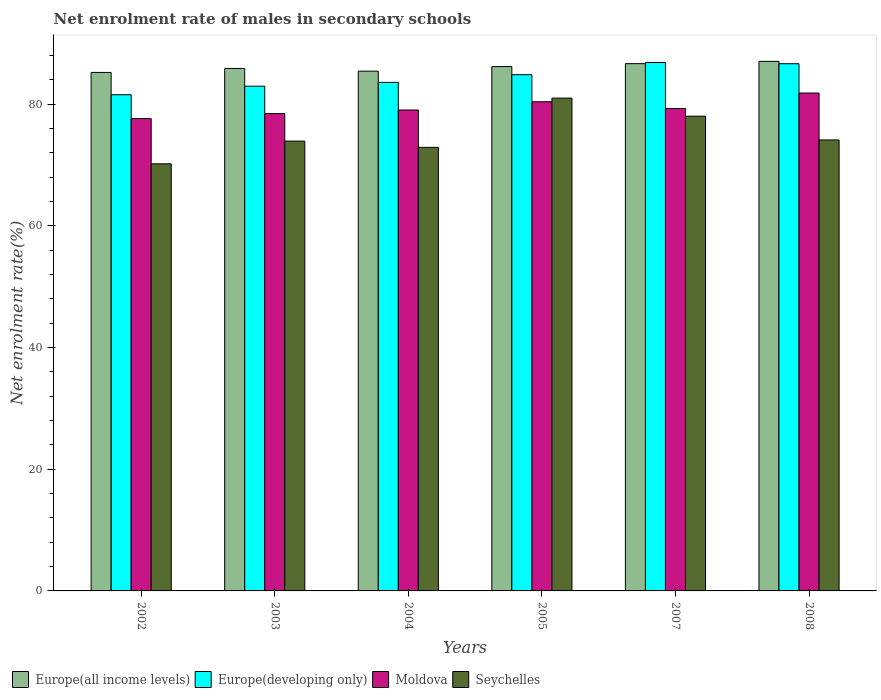How many different coloured bars are there?
Make the answer very short. 4. How many bars are there on the 3rd tick from the left?
Provide a short and direct response. 4. What is the label of the 3rd group of bars from the left?
Keep it short and to the point. 2004. What is the net enrolment rate of males in secondary schools in Moldova in 2004?
Your answer should be compact. 79.05. Across all years, what is the maximum net enrolment rate of males in secondary schools in Europe(developing only)?
Your answer should be compact. 86.86. Across all years, what is the minimum net enrolment rate of males in secondary schools in Europe(developing only)?
Your answer should be compact. 81.56. In which year was the net enrolment rate of males in secondary schools in Moldova maximum?
Offer a very short reply. 2008. In which year was the net enrolment rate of males in secondary schools in Seychelles minimum?
Make the answer very short. 2002. What is the total net enrolment rate of males in secondary schools in Europe(developing only) in the graph?
Your answer should be compact. 506.49. What is the difference between the net enrolment rate of males in secondary schools in Europe(all income levels) in 2002 and that in 2008?
Offer a very short reply. -1.82. What is the difference between the net enrolment rate of males in secondary schools in Europe(all income levels) in 2007 and the net enrolment rate of males in secondary schools in Seychelles in 2005?
Make the answer very short. 5.67. What is the average net enrolment rate of males in secondary schools in Europe(all income levels) per year?
Ensure brevity in your answer.  86.08. In the year 2004, what is the difference between the net enrolment rate of males in secondary schools in Moldova and net enrolment rate of males in secondary schools in Seychelles?
Provide a short and direct response. 6.14. In how many years, is the net enrolment rate of males in secondary schools in Europe(all income levels) greater than 52 %?
Ensure brevity in your answer.  6. What is the ratio of the net enrolment rate of males in secondary schools in Moldova in 2004 to that in 2008?
Provide a succinct answer. 0.97. Is the net enrolment rate of males in secondary schools in Seychelles in 2002 less than that in 2003?
Provide a succinct answer. Yes. What is the difference between the highest and the second highest net enrolment rate of males in secondary schools in Moldova?
Offer a terse response. 1.43. What is the difference between the highest and the lowest net enrolment rate of males in secondary schools in Seychelles?
Offer a terse response. 10.8. What does the 1st bar from the left in 2003 represents?
Make the answer very short. Europe(all income levels). What does the 4th bar from the right in 2003 represents?
Offer a very short reply. Europe(all income levels). How many bars are there?
Make the answer very short. 24. Are all the bars in the graph horizontal?
Give a very brief answer. No. How many years are there in the graph?
Your answer should be very brief. 6. What is the difference between two consecutive major ticks on the Y-axis?
Your answer should be very brief. 20. Where does the legend appear in the graph?
Make the answer very short. Bottom left. What is the title of the graph?
Your answer should be compact. Net enrolment rate of males in secondary schools. What is the label or title of the X-axis?
Your answer should be compact. Years. What is the label or title of the Y-axis?
Offer a very short reply. Net enrolment rate(%). What is the Net enrolment rate(%) in Europe(all income levels) in 2002?
Keep it short and to the point. 85.23. What is the Net enrolment rate(%) of Europe(developing only) in 2002?
Give a very brief answer. 81.56. What is the Net enrolment rate(%) of Moldova in 2002?
Your response must be concise. 77.65. What is the Net enrolment rate(%) of Seychelles in 2002?
Provide a short and direct response. 70.21. What is the Net enrolment rate(%) in Europe(all income levels) in 2003?
Give a very brief answer. 85.88. What is the Net enrolment rate(%) of Europe(developing only) in 2003?
Your response must be concise. 82.96. What is the Net enrolment rate(%) of Moldova in 2003?
Your response must be concise. 78.47. What is the Net enrolment rate(%) of Seychelles in 2003?
Offer a very short reply. 73.94. What is the Net enrolment rate(%) in Europe(all income levels) in 2004?
Make the answer very short. 85.44. What is the Net enrolment rate(%) of Europe(developing only) in 2004?
Your answer should be compact. 83.59. What is the Net enrolment rate(%) of Moldova in 2004?
Your answer should be very brief. 79.05. What is the Net enrolment rate(%) in Seychelles in 2004?
Offer a very short reply. 72.91. What is the Net enrolment rate(%) of Europe(all income levels) in 2005?
Give a very brief answer. 86.19. What is the Net enrolment rate(%) of Europe(developing only) in 2005?
Your response must be concise. 84.86. What is the Net enrolment rate(%) in Moldova in 2005?
Give a very brief answer. 80.41. What is the Net enrolment rate(%) in Seychelles in 2005?
Your answer should be compact. 81. What is the Net enrolment rate(%) of Europe(all income levels) in 2007?
Ensure brevity in your answer.  86.67. What is the Net enrolment rate(%) in Europe(developing only) in 2007?
Keep it short and to the point. 86.86. What is the Net enrolment rate(%) in Moldova in 2007?
Your response must be concise. 79.3. What is the Net enrolment rate(%) in Seychelles in 2007?
Make the answer very short. 78.04. What is the Net enrolment rate(%) in Europe(all income levels) in 2008?
Your response must be concise. 87.05. What is the Net enrolment rate(%) of Europe(developing only) in 2008?
Give a very brief answer. 86.66. What is the Net enrolment rate(%) of Moldova in 2008?
Ensure brevity in your answer.  81.84. What is the Net enrolment rate(%) in Seychelles in 2008?
Your response must be concise. 74.13. Across all years, what is the maximum Net enrolment rate(%) in Europe(all income levels)?
Your answer should be compact. 87.05. Across all years, what is the maximum Net enrolment rate(%) of Europe(developing only)?
Your answer should be compact. 86.86. Across all years, what is the maximum Net enrolment rate(%) of Moldova?
Offer a terse response. 81.84. Across all years, what is the maximum Net enrolment rate(%) of Seychelles?
Ensure brevity in your answer.  81. Across all years, what is the minimum Net enrolment rate(%) of Europe(all income levels)?
Your answer should be compact. 85.23. Across all years, what is the minimum Net enrolment rate(%) of Europe(developing only)?
Offer a terse response. 81.56. Across all years, what is the minimum Net enrolment rate(%) of Moldova?
Your answer should be very brief. 77.65. Across all years, what is the minimum Net enrolment rate(%) of Seychelles?
Your answer should be very brief. 70.21. What is the total Net enrolment rate(%) of Europe(all income levels) in the graph?
Your answer should be compact. 516.45. What is the total Net enrolment rate(%) of Europe(developing only) in the graph?
Your answer should be very brief. 506.49. What is the total Net enrolment rate(%) of Moldova in the graph?
Your response must be concise. 476.72. What is the total Net enrolment rate(%) in Seychelles in the graph?
Provide a succinct answer. 450.22. What is the difference between the Net enrolment rate(%) in Europe(all income levels) in 2002 and that in 2003?
Your response must be concise. -0.65. What is the difference between the Net enrolment rate(%) of Europe(developing only) in 2002 and that in 2003?
Provide a short and direct response. -1.4. What is the difference between the Net enrolment rate(%) in Moldova in 2002 and that in 2003?
Make the answer very short. -0.82. What is the difference between the Net enrolment rate(%) in Seychelles in 2002 and that in 2003?
Give a very brief answer. -3.73. What is the difference between the Net enrolment rate(%) in Europe(all income levels) in 2002 and that in 2004?
Your answer should be very brief. -0.21. What is the difference between the Net enrolment rate(%) of Europe(developing only) in 2002 and that in 2004?
Keep it short and to the point. -2.03. What is the difference between the Net enrolment rate(%) of Moldova in 2002 and that in 2004?
Ensure brevity in your answer.  -1.41. What is the difference between the Net enrolment rate(%) in Seychelles in 2002 and that in 2004?
Give a very brief answer. -2.71. What is the difference between the Net enrolment rate(%) in Europe(all income levels) in 2002 and that in 2005?
Offer a terse response. -0.96. What is the difference between the Net enrolment rate(%) in Europe(developing only) in 2002 and that in 2005?
Keep it short and to the point. -3.29. What is the difference between the Net enrolment rate(%) of Moldova in 2002 and that in 2005?
Provide a short and direct response. -2.76. What is the difference between the Net enrolment rate(%) of Seychelles in 2002 and that in 2005?
Your answer should be very brief. -10.8. What is the difference between the Net enrolment rate(%) of Europe(all income levels) in 2002 and that in 2007?
Provide a succinct answer. -1.44. What is the difference between the Net enrolment rate(%) in Europe(developing only) in 2002 and that in 2007?
Provide a succinct answer. -5.29. What is the difference between the Net enrolment rate(%) of Moldova in 2002 and that in 2007?
Provide a succinct answer. -1.65. What is the difference between the Net enrolment rate(%) in Seychelles in 2002 and that in 2007?
Offer a terse response. -7.83. What is the difference between the Net enrolment rate(%) of Europe(all income levels) in 2002 and that in 2008?
Ensure brevity in your answer.  -1.82. What is the difference between the Net enrolment rate(%) of Europe(developing only) in 2002 and that in 2008?
Provide a succinct answer. -5.1. What is the difference between the Net enrolment rate(%) in Moldova in 2002 and that in 2008?
Your answer should be very brief. -4.19. What is the difference between the Net enrolment rate(%) in Seychelles in 2002 and that in 2008?
Your response must be concise. -3.92. What is the difference between the Net enrolment rate(%) of Europe(all income levels) in 2003 and that in 2004?
Make the answer very short. 0.44. What is the difference between the Net enrolment rate(%) of Europe(developing only) in 2003 and that in 2004?
Keep it short and to the point. -0.63. What is the difference between the Net enrolment rate(%) in Moldova in 2003 and that in 2004?
Your response must be concise. -0.58. What is the difference between the Net enrolment rate(%) in Seychelles in 2003 and that in 2004?
Offer a very short reply. 1.03. What is the difference between the Net enrolment rate(%) in Europe(all income levels) in 2003 and that in 2005?
Give a very brief answer. -0.31. What is the difference between the Net enrolment rate(%) of Europe(developing only) in 2003 and that in 2005?
Offer a terse response. -1.89. What is the difference between the Net enrolment rate(%) in Moldova in 2003 and that in 2005?
Give a very brief answer. -1.94. What is the difference between the Net enrolment rate(%) of Seychelles in 2003 and that in 2005?
Offer a terse response. -7.07. What is the difference between the Net enrolment rate(%) of Europe(all income levels) in 2003 and that in 2007?
Make the answer very short. -0.79. What is the difference between the Net enrolment rate(%) in Europe(developing only) in 2003 and that in 2007?
Provide a short and direct response. -3.89. What is the difference between the Net enrolment rate(%) in Moldova in 2003 and that in 2007?
Give a very brief answer. -0.83. What is the difference between the Net enrolment rate(%) in Seychelles in 2003 and that in 2007?
Give a very brief answer. -4.1. What is the difference between the Net enrolment rate(%) of Europe(all income levels) in 2003 and that in 2008?
Offer a terse response. -1.17. What is the difference between the Net enrolment rate(%) of Europe(developing only) in 2003 and that in 2008?
Offer a terse response. -3.69. What is the difference between the Net enrolment rate(%) of Moldova in 2003 and that in 2008?
Keep it short and to the point. -3.37. What is the difference between the Net enrolment rate(%) in Seychelles in 2003 and that in 2008?
Provide a short and direct response. -0.19. What is the difference between the Net enrolment rate(%) in Europe(all income levels) in 2004 and that in 2005?
Provide a short and direct response. -0.75. What is the difference between the Net enrolment rate(%) of Europe(developing only) in 2004 and that in 2005?
Ensure brevity in your answer.  -1.26. What is the difference between the Net enrolment rate(%) of Moldova in 2004 and that in 2005?
Give a very brief answer. -1.36. What is the difference between the Net enrolment rate(%) in Seychelles in 2004 and that in 2005?
Provide a succinct answer. -8.09. What is the difference between the Net enrolment rate(%) of Europe(all income levels) in 2004 and that in 2007?
Keep it short and to the point. -1.23. What is the difference between the Net enrolment rate(%) of Europe(developing only) in 2004 and that in 2007?
Your response must be concise. -3.26. What is the difference between the Net enrolment rate(%) in Moldova in 2004 and that in 2007?
Your answer should be compact. -0.25. What is the difference between the Net enrolment rate(%) in Seychelles in 2004 and that in 2007?
Give a very brief answer. -5.13. What is the difference between the Net enrolment rate(%) in Europe(all income levels) in 2004 and that in 2008?
Keep it short and to the point. -1.61. What is the difference between the Net enrolment rate(%) in Europe(developing only) in 2004 and that in 2008?
Your response must be concise. -3.07. What is the difference between the Net enrolment rate(%) in Moldova in 2004 and that in 2008?
Your answer should be compact. -2.79. What is the difference between the Net enrolment rate(%) of Seychelles in 2004 and that in 2008?
Provide a succinct answer. -1.22. What is the difference between the Net enrolment rate(%) of Europe(all income levels) in 2005 and that in 2007?
Your answer should be very brief. -0.48. What is the difference between the Net enrolment rate(%) of Europe(developing only) in 2005 and that in 2007?
Your answer should be compact. -2. What is the difference between the Net enrolment rate(%) in Moldova in 2005 and that in 2007?
Offer a terse response. 1.11. What is the difference between the Net enrolment rate(%) of Seychelles in 2005 and that in 2007?
Offer a terse response. 2.97. What is the difference between the Net enrolment rate(%) in Europe(all income levels) in 2005 and that in 2008?
Make the answer very short. -0.86. What is the difference between the Net enrolment rate(%) in Europe(developing only) in 2005 and that in 2008?
Provide a short and direct response. -1.8. What is the difference between the Net enrolment rate(%) of Moldova in 2005 and that in 2008?
Your answer should be compact. -1.43. What is the difference between the Net enrolment rate(%) of Seychelles in 2005 and that in 2008?
Offer a terse response. 6.88. What is the difference between the Net enrolment rate(%) of Europe(all income levels) in 2007 and that in 2008?
Your response must be concise. -0.38. What is the difference between the Net enrolment rate(%) in Europe(developing only) in 2007 and that in 2008?
Offer a very short reply. 0.2. What is the difference between the Net enrolment rate(%) in Moldova in 2007 and that in 2008?
Offer a very short reply. -2.54. What is the difference between the Net enrolment rate(%) in Seychelles in 2007 and that in 2008?
Give a very brief answer. 3.91. What is the difference between the Net enrolment rate(%) of Europe(all income levels) in 2002 and the Net enrolment rate(%) of Europe(developing only) in 2003?
Your response must be concise. 2.26. What is the difference between the Net enrolment rate(%) of Europe(all income levels) in 2002 and the Net enrolment rate(%) of Moldova in 2003?
Your response must be concise. 6.76. What is the difference between the Net enrolment rate(%) in Europe(all income levels) in 2002 and the Net enrolment rate(%) in Seychelles in 2003?
Provide a succinct answer. 11.29. What is the difference between the Net enrolment rate(%) in Europe(developing only) in 2002 and the Net enrolment rate(%) in Moldova in 2003?
Provide a short and direct response. 3.1. What is the difference between the Net enrolment rate(%) of Europe(developing only) in 2002 and the Net enrolment rate(%) of Seychelles in 2003?
Ensure brevity in your answer.  7.63. What is the difference between the Net enrolment rate(%) of Moldova in 2002 and the Net enrolment rate(%) of Seychelles in 2003?
Give a very brief answer. 3.71. What is the difference between the Net enrolment rate(%) of Europe(all income levels) in 2002 and the Net enrolment rate(%) of Europe(developing only) in 2004?
Your response must be concise. 1.64. What is the difference between the Net enrolment rate(%) of Europe(all income levels) in 2002 and the Net enrolment rate(%) of Moldova in 2004?
Ensure brevity in your answer.  6.18. What is the difference between the Net enrolment rate(%) of Europe(all income levels) in 2002 and the Net enrolment rate(%) of Seychelles in 2004?
Your response must be concise. 12.32. What is the difference between the Net enrolment rate(%) in Europe(developing only) in 2002 and the Net enrolment rate(%) in Moldova in 2004?
Ensure brevity in your answer.  2.51. What is the difference between the Net enrolment rate(%) in Europe(developing only) in 2002 and the Net enrolment rate(%) in Seychelles in 2004?
Your answer should be compact. 8.65. What is the difference between the Net enrolment rate(%) of Moldova in 2002 and the Net enrolment rate(%) of Seychelles in 2004?
Your answer should be compact. 4.73. What is the difference between the Net enrolment rate(%) of Europe(all income levels) in 2002 and the Net enrolment rate(%) of Europe(developing only) in 2005?
Your answer should be compact. 0.37. What is the difference between the Net enrolment rate(%) of Europe(all income levels) in 2002 and the Net enrolment rate(%) of Moldova in 2005?
Make the answer very short. 4.82. What is the difference between the Net enrolment rate(%) of Europe(all income levels) in 2002 and the Net enrolment rate(%) of Seychelles in 2005?
Offer a terse response. 4.22. What is the difference between the Net enrolment rate(%) of Europe(developing only) in 2002 and the Net enrolment rate(%) of Moldova in 2005?
Provide a succinct answer. 1.15. What is the difference between the Net enrolment rate(%) in Europe(developing only) in 2002 and the Net enrolment rate(%) in Seychelles in 2005?
Offer a terse response. 0.56. What is the difference between the Net enrolment rate(%) in Moldova in 2002 and the Net enrolment rate(%) in Seychelles in 2005?
Make the answer very short. -3.36. What is the difference between the Net enrolment rate(%) of Europe(all income levels) in 2002 and the Net enrolment rate(%) of Europe(developing only) in 2007?
Ensure brevity in your answer.  -1.63. What is the difference between the Net enrolment rate(%) in Europe(all income levels) in 2002 and the Net enrolment rate(%) in Moldova in 2007?
Your answer should be compact. 5.93. What is the difference between the Net enrolment rate(%) of Europe(all income levels) in 2002 and the Net enrolment rate(%) of Seychelles in 2007?
Provide a short and direct response. 7.19. What is the difference between the Net enrolment rate(%) of Europe(developing only) in 2002 and the Net enrolment rate(%) of Moldova in 2007?
Provide a short and direct response. 2.26. What is the difference between the Net enrolment rate(%) in Europe(developing only) in 2002 and the Net enrolment rate(%) in Seychelles in 2007?
Your answer should be very brief. 3.53. What is the difference between the Net enrolment rate(%) in Moldova in 2002 and the Net enrolment rate(%) in Seychelles in 2007?
Your answer should be very brief. -0.39. What is the difference between the Net enrolment rate(%) of Europe(all income levels) in 2002 and the Net enrolment rate(%) of Europe(developing only) in 2008?
Your response must be concise. -1.43. What is the difference between the Net enrolment rate(%) of Europe(all income levels) in 2002 and the Net enrolment rate(%) of Moldova in 2008?
Provide a short and direct response. 3.39. What is the difference between the Net enrolment rate(%) in Europe(all income levels) in 2002 and the Net enrolment rate(%) in Seychelles in 2008?
Keep it short and to the point. 11.1. What is the difference between the Net enrolment rate(%) in Europe(developing only) in 2002 and the Net enrolment rate(%) in Moldova in 2008?
Provide a short and direct response. -0.28. What is the difference between the Net enrolment rate(%) in Europe(developing only) in 2002 and the Net enrolment rate(%) in Seychelles in 2008?
Offer a very short reply. 7.43. What is the difference between the Net enrolment rate(%) of Moldova in 2002 and the Net enrolment rate(%) of Seychelles in 2008?
Offer a terse response. 3.52. What is the difference between the Net enrolment rate(%) in Europe(all income levels) in 2003 and the Net enrolment rate(%) in Europe(developing only) in 2004?
Offer a very short reply. 2.29. What is the difference between the Net enrolment rate(%) in Europe(all income levels) in 2003 and the Net enrolment rate(%) in Moldova in 2004?
Make the answer very short. 6.83. What is the difference between the Net enrolment rate(%) in Europe(all income levels) in 2003 and the Net enrolment rate(%) in Seychelles in 2004?
Ensure brevity in your answer.  12.97. What is the difference between the Net enrolment rate(%) in Europe(developing only) in 2003 and the Net enrolment rate(%) in Moldova in 2004?
Make the answer very short. 3.91. What is the difference between the Net enrolment rate(%) of Europe(developing only) in 2003 and the Net enrolment rate(%) of Seychelles in 2004?
Give a very brief answer. 10.05. What is the difference between the Net enrolment rate(%) of Moldova in 2003 and the Net enrolment rate(%) of Seychelles in 2004?
Offer a terse response. 5.56. What is the difference between the Net enrolment rate(%) of Europe(all income levels) in 2003 and the Net enrolment rate(%) of Moldova in 2005?
Provide a short and direct response. 5.47. What is the difference between the Net enrolment rate(%) of Europe(all income levels) in 2003 and the Net enrolment rate(%) of Seychelles in 2005?
Keep it short and to the point. 4.87. What is the difference between the Net enrolment rate(%) in Europe(developing only) in 2003 and the Net enrolment rate(%) in Moldova in 2005?
Ensure brevity in your answer.  2.56. What is the difference between the Net enrolment rate(%) of Europe(developing only) in 2003 and the Net enrolment rate(%) of Seychelles in 2005?
Provide a short and direct response. 1.96. What is the difference between the Net enrolment rate(%) in Moldova in 2003 and the Net enrolment rate(%) in Seychelles in 2005?
Give a very brief answer. -2.54. What is the difference between the Net enrolment rate(%) of Europe(all income levels) in 2003 and the Net enrolment rate(%) of Europe(developing only) in 2007?
Provide a succinct answer. -0.98. What is the difference between the Net enrolment rate(%) in Europe(all income levels) in 2003 and the Net enrolment rate(%) in Moldova in 2007?
Give a very brief answer. 6.58. What is the difference between the Net enrolment rate(%) in Europe(all income levels) in 2003 and the Net enrolment rate(%) in Seychelles in 2007?
Offer a terse response. 7.84. What is the difference between the Net enrolment rate(%) in Europe(developing only) in 2003 and the Net enrolment rate(%) in Moldova in 2007?
Your answer should be compact. 3.66. What is the difference between the Net enrolment rate(%) of Europe(developing only) in 2003 and the Net enrolment rate(%) of Seychelles in 2007?
Provide a short and direct response. 4.93. What is the difference between the Net enrolment rate(%) of Moldova in 2003 and the Net enrolment rate(%) of Seychelles in 2007?
Offer a very short reply. 0.43. What is the difference between the Net enrolment rate(%) of Europe(all income levels) in 2003 and the Net enrolment rate(%) of Europe(developing only) in 2008?
Provide a succinct answer. -0.78. What is the difference between the Net enrolment rate(%) in Europe(all income levels) in 2003 and the Net enrolment rate(%) in Moldova in 2008?
Provide a short and direct response. 4.04. What is the difference between the Net enrolment rate(%) in Europe(all income levels) in 2003 and the Net enrolment rate(%) in Seychelles in 2008?
Offer a terse response. 11.75. What is the difference between the Net enrolment rate(%) of Europe(developing only) in 2003 and the Net enrolment rate(%) of Moldova in 2008?
Provide a succinct answer. 1.12. What is the difference between the Net enrolment rate(%) in Europe(developing only) in 2003 and the Net enrolment rate(%) in Seychelles in 2008?
Keep it short and to the point. 8.84. What is the difference between the Net enrolment rate(%) in Moldova in 2003 and the Net enrolment rate(%) in Seychelles in 2008?
Ensure brevity in your answer.  4.34. What is the difference between the Net enrolment rate(%) in Europe(all income levels) in 2004 and the Net enrolment rate(%) in Europe(developing only) in 2005?
Offer a terse response. 0.58. What is the difference between the Net enrolment rate(%) of Europe(all income levels) in 2004 and the Net enrolment rate(%) of Moldova in 2005?
Your answer should be compact. 5.03. What is the difference between the Net enrolment rate(%) of Europe(all income levels) in 2004 and the Net enrolment rate(%) of Seychelles in 2005?
Give a very brief answer. 4.43. What is the difference between the Net enrolment rate(%) of Europe(developing only) in 2004 and the Net enrolment rate(%) of Moldova in 2005?
Provide a short and direct response. 3.18. What is the difference between the Net enrolment rate(%) in Europe(developing only) in 2004 and the Net enrolment rate(%) in Seychelles in 2005?
Provide a succinct answer. 2.59. What is the difference between the Net enrolment rate(%) in Moldova in 2004 and the Net enrolment rate(%) in Seychelles in 2005?
Provide a short and direct response. -1.95. What is the difference between the Net enrolment rate(%) of Europe(all income levels) in 2004 and the Net enrolment rate(%) of Europe(developing only) in 2007?
Ensure brevity in your answer.  -1.42. What is the difference between the Net enrolment rate(%) of Europe(all income levels) in 2004 and the Net enrolment rate(%) of Moldova in 2007?
Make the answer very short. 6.14. What is the difference between the Net enrolment rate(%) of Europe(all income levels) in 2004 and the Net enrolment rate(%) of Seychelles in 2007?
Provide a succinct answer. 7.4. What is the difference between the Net enrolment rate(%) of Europe(developing only) in 2004 and the Net enrolment rate(%) of Moldova in 2007?
Provide a succinct answer. 4.29. What is the difference between the Net enrolment rate(%) in Europe(developing only) in 2004 and the Net enrolment rate(%) in Seychelles in 2007?
Your response must be concise. 5.56. What is the difference between the Net enrolment rate(%) of Moldova in 2004 and the Net enrolment rate(%) of Seychelles in 2007?
Keep it short and to the point. 1.02. What is the difference between the Net enrolment rate(%) of Europe(all income levels) in 2004 and the Net enrolment rate(%) of Europe(developing only) in 2008?
Offer a very short reply. -1.22. What is the difference between the Net enrolment rate(%) in Europe(all income levels) in 2004 and the Net enrolment rate(%) in Moldova in 2008?
Provide a succinct answer. 3.6. What is the difference between the Net enrolment rate(%) in Europe(all income levels) in 2004 and the Net enrolment rate(%) in Seychelles in 2008?
Give a very brief answer. 11.31. What is the difference between the Net enrolment rate(%) in Europe(developing only) in 2004 and the Net enrolment rate(%) in Moldova in 2008?
Give a very brief answer. 1.75. What is the difference between the Net enrolment rate(%) in Europe(developing only) in 2004 and the Net enrolment rate(%) in Seychelles in 2008?
Give a very brief answer. 9.46. What is the difference between the Net enrolment rate(%) of Moldova in 2004 and the Net enrolment rate(%) of Seychelles in 2008?
Offer a terse response. 4.92. What is the difference between the Net enrolment rate(%) of Europe(all income levels) in 2005 and the Net enrolment rate(%) of Europe(developing only) in 2007?
Make the answer very short. -0.67. What is the difference between the Net enrolment rate(%) of Europe(all income levels) in 2005 and the Net enrolment rate(%) of Moldova in 2007?
Offer a very short reply. 6.89. What is the difference between the Net enrolment rate(%) in Europe(all income levels) in 2005 and the Net enrolment rate(%) in Seychelles in 2007?
Provide a short and direct response. 8.15. What is the difference between the Net enrolment rate(%) of Europe(developing only) in 2005 and the Net enrolment rate(%) of Moldova in 2007?
Provide a short and direct response. 5.56. What is the difference between the Net enrolment rate(%) in Europe(developing only) in 2005 and the Net enrolment rate(%) in Seychelles in 2007?
Provide a succinct answer. 6.82. What is the difference between the Net enrolment rate(%) of Moldova in 2005 and the Net enrolment rate(%) of Seychelles in 2007?
Ensure brevity in your answer.  2.37. What is the difference between the Net enrolment rate(%) in Europe(all income levels) in 2005 and the Net enrolment rate(%) in Europe(developing only) in 2008?
Your response must be concise. -0.47. What is the difference between the Net enrolment rate(%) in Europe(all income levels) in 2005 and the Net enrolment rate(%) in Moldova in 2008?
Your response must be concise. 4.35. What is the difference between the Net enrolment rate(%) of Europe(all income levels) in 2005 and the Net enrolment rate(%) of Seychelles in 2008?
Provide a short and direct response. 12.06. What is the difference between the Net enrolment rate(%) of Europe(developing only) in 2005 and the Net enrolment rate(%) of Moldova in 2008?
Offer a very short reply. 3.02. What is the difference between the Net enrolment rate(%) of Europe(developing only) in 2005 and the Net enrolment rate(%) of Seychelles in 2008?
Your answer should be very brief. 10.73. What is the difference between the Net enrolment rate(%) in Moldova in 2005 and the Net enrolment rate(%) in Seychelles in 2008?
Your response must be concise. 6.28. What is the difference between the Net enrolment rate(%) of Europe(all income levels) in 2007 and the Net enrolment rate(%) of Europe(developing only) in 2008?
Provide a succinct answer. 0.01. What is the difference between the Net enrolment rate(%) of Europe(all income levels) in 2007 and the Net enrolment rate(%) of Moldova in 2008?
Keep it short and to the point. 4.83. What is the difference between the Net enrolment rate(%) of Europe(all income levels) in 2007 and the Net enrolment rate(%) of Seychelles in 2008?
Ensure brevity in your answer.  12.54. What is the difference between the Net enrolment rate(%) of Europe(developing only) in 2007 and the Net enrolment rate(%) of Moldova in 2008?
Keep it short and to the point. 5.02. What is the difference between the Net enrolment rate(%) of Europe(developing only) in 2007 and the Net enrolment rate(%) of Seychelles in 2008?
Your response must be concise. 12.73. What is the difference between the Net enrolment rate(%) in Moldova in 2007 and the Net enrolment rate(%) in Seychelles in 2008?
Offer a terse response. 5.17. What is the average Net enrolment rate(%) in Europe(all income levels) per year?
Ensure brevity in your answer.  86.08. What is the average Net enrolment rate(%) of Europe(developing only) per year?
Ensure brevity in your answer.  84.42. What is the average Net enrolment rate(%) of Moldova per year?
Offer a terse response. 79.45. What is the average Net enrolment rate(%) in Seychelles per year?
Offer a terse response. 75.04. In the year 2002, what is the difference between the Net enrolment rate(%) of Europe(all income levels) and Net enrolment rate(%) of Europe(developing only)?
Make the answer very short. 3.66. In the year 2002, what is the difference between the Net enrolment rate(%) in Europe(all income levels) and Net enrolment rate(%) in Moldova?
Offer a very short reply. 7.58. In the year 2002, what is the difference between the Net enrolment rate(%) of Europe(all income levels) and Net enrolment rate(%) of Seychelles?
Provide a succinct answer. 15.02. In the year 2002, what is the difference between the Net enrolment rate(%) of Europe(developing only) and Net enrolment rate(%) of Moldova?
Ensure brevity in your answer.  3.92. In the year 2002, what is the difference between the Net enrolment rate(%) of Europe(developing only) and Net enrolment rate(%) of Seychelles?
Provide a short and direct response. 11.36. In the year 2002, what is the difference between the Net enrolment rate(%) of Moldova and Net enrolment rate(%) of Seychelles?
Offer a very short reply. 7.44. In the year 2003, what is the difference between the Net enrolment rate(%) in Europe(all income levels) and Net enrolment rate(%) in Europe(developing only)?
Ensure brevity in your answer.  2.91. In the year 2003, what is the difference between the Net enrolment rate(%) of Europe(all income levels) and Net enrolment rate(%) of Moldova?
Give a very brief answer. 7.41. In the year 2003, what is the difference between the Net enrolment rate(%) in Europe(all income levels) and Net enrolment rate(%) in Seychelles?
Make the answer very short. 11.94. In the year 2003, what is the difference between the Net enrolment rate(%) of Europe(developing only) and Net enrolment rate(%) of Moldova?
Your response must be concise. 4.5. In the year 2003, what is the difference between the Net enrolment rate(%) of Europe(developing only) and Net enrolment rate(%) of Seychelles?
Provide a succinct answer. 9.03. In the year 2003, what is the difference between the Net enrolment rate(%) in Moldova and Net enrolment rate(%) in Seychelles?
Give a very brief answer. 4.53. In the year 2004, what is the difference between the Net enrolment rate(%) of Europe(all income levels) and Net enrolment rate(%) of Europe(developing only)?
Your answer should be very brief. 1.84. In the year 2004, what is the difference between the Net enrolment rate(%) of Europe(all income levels) and Net enrolment rate(%) of Moldova?
Keep it short and to the point. 6.38. In the year 2004, what is the difference between the Net enrolment rate(%) in Europe(all income levels) and Net enrolment rate(%) in Seychelles?
Ensure brevity in your answer.  12.53. In the year 2004, what is the difference between the Net enrolment rate(%) in Europe(developing only) and Net enrolment rate(%) in Moldova?
Provide a short and direct response. 4.54. In the year 2004, what is the difference between the Net enrolment rate(%) of Europe(developing only) and Net enrolment rate(%) of Seychelles?
Ensure brevity in your answer.  10.68. In the year 2004, what is the difference between the Net enrolment rate(%) in Moldova and Net enrolment rate(%) in Seychelles?
Provide a succinct answer. 6.14. In the year 2005, what is the difference between the Net enrolment rate(%) of Europe(all income levels) and Net enrolment rate(%) of Europe(developing only)?
Your response must be concise. 1.34. In the year 2005, what is the difference between the Net enrolment rate(%) of Europe(all income levels) and Net enrolment rate(%) of Moldova?
Offer a very short reply. 5.78. In the year 2005, what is the difference between the Net enrolment rate(%) of Europe(all income levels) and Net enrolment rate(%) of Seychelles?
Ensure brevity in your answer.  5.19. In the year 2005, what is the difference between the Net enrolment rate(%) of Europe(developing only) and Net enrolment rate(%) of Moldova?
Keep it short and to the point. 4.45. In the year 2005, what is the difference between the Net enrolment rate(%) of Europe(developing only) and Net enrolment rate(%) of Seychelles?
Your answer should be very brief. 3.85. In the year 2005, what is the difference between the Net enrolment rate(%) of Moldova and Net enrolment rate(%) of Seychelles?
Your answer should be very brief. -0.59. In the year 2007, what is the difference between the Net enrolment rate(%) of Europe(all income levels) and Net enrolment rate(%) of Europe(developing only)?
Give a very brief answer. -0.19. In the year 2007, what is the difference between the Net enrolment rate(%) in Europe(all income levels) and Net enrolment rate(%) in Moldova?
Give a very brief answer. 7.37. In the year 2007, what is the difference between the Net enrolment rate(%) of Europe(all income levels) and Net enrolment rate(%) of Seychelles?
Make the answer very short. 8.63. In the year 2007, what is the difference between the Net enrolment rate(%) in Europe(developing only) and Net enrolment rate(%) in Moldova?
Your answer should be compact. 7.56. In the year 2007, what is the difference between the Net enrolment rate(%) of Europe(developing only) and Net enrolment rate(%) of Seychelles?
Provide a succinct answer. 8.82. In the year 2007, what is the difference between the Net enrolment rate(%) of Moldova and Net enrolment rate(%) of Seychelles?
Provide a short and direct response. 1.26. In the year 2008, what is the difference between the Net enrolment rate(%) of Europe(all income levels) and Net enrolment rate(%) of Europe(developing only)?
Provide a short and direct response. 0.39. In the year 2008, what is the difference between the Net enrolment rate(%) in Europe(all income levels) and Net enrolment rate(%) in Moldova?
Ensure brevity in your answer.  5.21. In the year 2008, what is the difference between the Net enrolment rate(%) of Europe(all income levels) and Net enrolment rate(%) of Seychelles?
Your answer should be very brief. 12.92. In the year 2008, what is the difference between the Net enrolment rate(%) of Europe(developing only) and Net enrolment rate(%) of Moldova?
Your answer should be compact. 4.82. In the year 2008, what is the difference between the Net enrolment rate(%) in Europe(developing only) and Net enrolment rate(%) in Seychelles?
Provide a short and direct response. 12.53. In the year 2008, what is the difference between the Net enrolment rate(%) of Moldova and Net enrolment rate(%) of Seychelles?
Keep it short and to the point. 7.71. What is the ratio of the Net enrolment rate(%) in Europe(all income levels) in 2002 to that in 2003?
Keep it short and to the point. 0.99. What is the ratio of the Net enrolment rate(%) of Europe(developing only) in 2002 to that in 2003?
Give a very brief answer. 0.98. What is the ratio of the Net enrolment rate(%) in Moldova in 2002 to that in 2003?
Give a very brief answer. 0.99. What is the ratio of the Net enrolment rate(%) in Seychelles in 2002 to that in 2003?
Ensure brevity in your answer.  0.95. What is the ratio of the Net enrolment rate(%) in Europe(developing only) in 2002 to that in 2004?
Offer a very short reply. 0.98. What is the ratio of the Net enrolment rate(%) of Moldova in 2002 to that in 2004?
Provide a short and direct response. 0.98. What is the ratio of the Net enrolment rate(%) of Seychelles in 2002 to that in 2004?
Keep it short and to the point. 0.96. What is the ratio of the Net enrolment rate(%) in Europe(developing only) in 2002 to that in 2005?
Your answer should be compact. 0.96. What is the ratio of the Net enrolment rate(%) of Moldova in 2002 to that in 2005?
Your response must be concise. 0.97. What is the ratio of the Net enrolment rate(%) of Seychelles in 2002 to that in 2005?
Your answer should be compact. 0.87. What is the ratio of the Net enrolment rate(%) of Europe(all income levels) in 2002 to that in 2007?
Provide a short and direct response. 0.98. What is the ratio of the Net enrolment rate(%) in Europe(developing only) in 2002 to that in 2007?
Keep it short and to the point. 0.94. What is the ratio of the Net enrolment rate(%) in Moldova in 2002 to that in 2007?
Offer a terse response. 0.98. What is the ratio of the Net enrolment rate(%) of Seychelles in 2002 to that in 2007?
Your response must be concise. 0.9. What is the ratio of the Net enrolment rate(%) of Europe(all income levels) in 2002 to that in 2008?
Offer a very short reply. 0.98. What is the ratio of the Net enrolment rate(%) in Moldova in 2002 to that in 2008?
Ensure brevity in your answer.  0.95. What is the ratio of the Net enrolment rate(%) of Seychelles in 2002 to that in 2008?
Your response must be concise. 0.95. What is the ratio of the Net enrolment rate(%) of Seychelles in 2003 to that in 2004?
Keep it short and to the point. 1.01. What is the ratio of the Net enrolment rate(%) of Europe(all income levels) in 2003 to that in 2005?
Keep it short and to the point. 1. What is the ratio of the Net enrolment rate(%) in Europe(developing only) in 2003 to that in 2005?
Ensure brevity in your answer.  0.98. What is the ratio of the Net enrolment rate(%) in Moldova in 2003 to that in 2005?
Your answer should be very brief. 0.98. What is the ratio of the Net enrolment rate(%) of Seychelles in 2003 to that in 2005?
Your answer should be compact. 0.91. What is the ratio of the Net enrolment rate(%) in Europe(all income levels) in 2003 to that in 2007?
Provide a succinct answer. 0.99. What is the ratio of the Net enrolment rate(%) in Europe(developing only) in 2003 to that in 2007?
Provide a succinct answer. 0.96. What is the ratio of the Net enrolment rate(%) of Moldova in 2003 to that in 2007?
Provide a succinct answer. 0.99. What is the ratio of the Net enrolment rate(%) in Seychelles in 2003 to that in 2007?
Keep it short and to the point. 0.95. What is the ratio of the Net enrolment rate(%) of Europe(all income levels) in 2003 to that in 2008?
Your answer should be very brief. 0.99. What is the ratio of the Net enrolment rate(%) in Europe(developing only) in 2003 to that in 2008?
Offer a terse response. 0.96. What is the ratio of the Net enrolment rate(%) in Moldova in 2003 to that in 2008?
Provide a short and direct response. 0.96. What is the ratio of the Net enrolment rate(%) in Europe(all income levels) in 2004 to that in 2005?
Ensure brevity in your answer.  0.99. What is the ratio of the Net enrolment rate(%) of Europe(developing only) in 2004 to that in 2005?
Provide a short and direct response. 0.99. What is the ratio of the Net enrolment rate(%) in Moldova in 2004 to that in 2005?
Provide a short and direct response. 0.98. What is the ratio of the Net enrolment rate(%) in Seychelles in 2004 to that in 2005?
Provide a succinct answer. 0.9. What is the ratio of the Net enrolment rate(%) in Europe(all income levels) in 2004 to that in 2007?
Ensure brevity in your answer.  0.99. What is the ratio of the Net enrolment rate(%) in Europe(developing only) in 2004 to that in 2007?
Give a very brief answer. 0.96. What is the ratio of the Net enrolment rate(%) of Moldova in 2004 to that in 2007?
Offer a terse response. 1. What is the ratio of the Net enrolment rate(%) in Seychelles in 2004 to that in 2007?
Make the answer very short. 0.93. What is the ratio of the Net enrolment rate(%) of Europe(all income levels) in 2004 to that in 2008?
Provide a short and direct response. 0.98. What is the ratio of the Net enrolment rate(%) of Europe(developing only) in 2004 to that in 2008?
Your response must be concise. 0.96. What is the ratio of the Net enrolment rate(%) in Moldova in 2004 to that in 2008?
Your response must be concise. 0.97. What is the ratio of the Net enrolment rate(%) of Seychelles in 2004 to that in 2008?
Make the answer very short. 0.98. What is the ratio of the Net enrolment rate(%) of Europe(all income levels) in 2005 to that in 2007?
Provide a succinct answer. 0.99. What is the ratio of the Net enrolment rate(%) of Europe(developing only) in 2005 to that in 2007?
Make the answer very short. 0.98. What is the ratio of the Net enrolment rate(%) in Moldova in 2005 to that in 2007?
Provide a short and direct response. 1.01. What is the ratio of the Net enrolment rate(%) in Seychelles in 2005 to that in 2007?
Provide a succinct answer. 1.04. What is the ratio of the Net enrolment rate(%) in Europe(all income levels) in 2005 to that in 2008?
Ensure brevity in your answer.  0.99. What is the ratio of the Net enrolment rate(%) in Europe(developing only) in 2005 to that in 2008?
Make the answer very short. 0.98. What is the ratio of the Net enrolment rate(%) in Moldova in 2005 to that in 2008?
Give a very brief answer. 0.98. What is the ratio of the Net enrolment rate(%) of Seychelles in 2005 to that in 2008?
Make the answer very short. 1.09. What is the ratio of the Net enrolment rate(%) of Europe(all income levels) in 2007 to that in 2008?
Keep it short and to the point. 1. What is the ratio of the Net enrolment rate(%) in Moldova in 2007 to that in 2008?
Ensure brevity in your answer.  0.97. What is the ratio of the Net enrolment rate(%) in Seychelles in 2007 to that in 2008?
Provide a short and direct response. 1.05. What is the difference between the highest and the second highest Net enrolment rate(%) in Europe(all income levels)?
Your response must be concise. 0.38. What is the difference between the highest and the second highest Net enrolment rate(%) of Europe(developing only)?
Provide a succinct answer. 0.2. What is the difference between the highest and the second highest Net enrolment rate(%) of Moldova?
Your answer should be very brief. 1.43. What is the difference between the highest and the second highest Net enrolment rate(%) in Seychelles?
Your answer should be very brief. 2.97. What is the difference between the highest and the lowest Net enrolment rate(%) in Europe(all income levels)?
Your answer should be very brief. 1.82. What is the difference between the highest and the lowest Net enrolment rate(%) in Europe(developing only)?
Make the answer very short. 5.29. What is the difference between the highest and the lowest Net enrolment rate(%) in Moldova?
Provide a succinct answer. 4.19. What is the difference between the highest and the lowest Net enrolment rate(%) in Seychelles?
Provide a succinct answer. 10.8. 